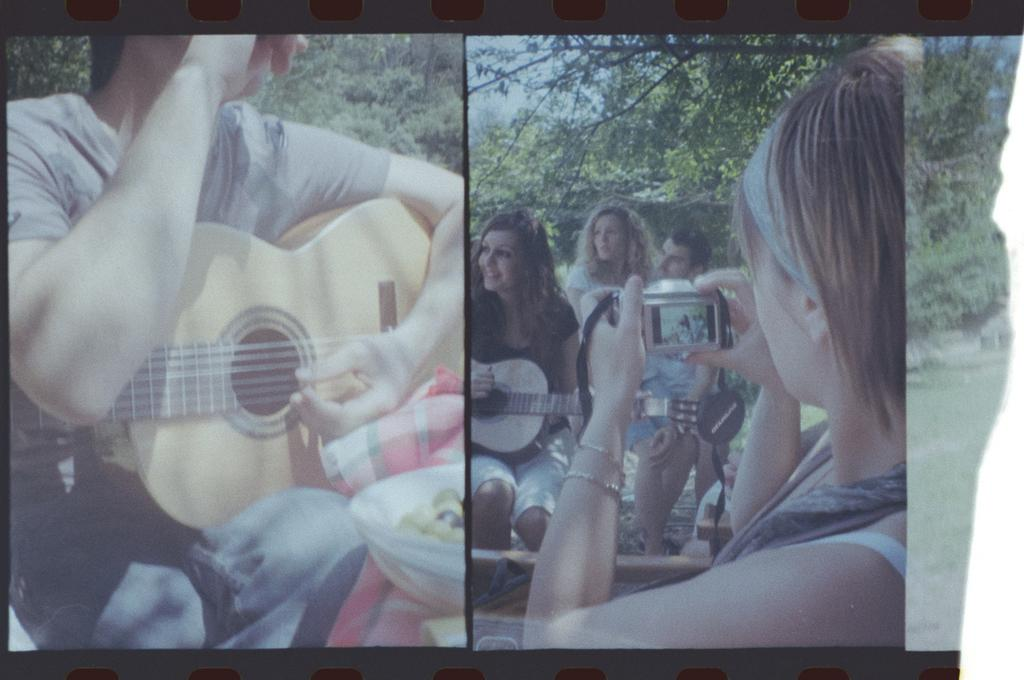What are the persons in the image doing? The persons in the image are sitting. What are two of the persons holding? Two persons are holding guitars. What is the third person holding? One person is holding a camera. What can be seen in the background of the image? There are trees in the background of the image. What type of vegetation is visible in the image? There is grass visible in the image. What type of lead can be seen connecting the guitar to the station in the image? There is no lead or station present in the image; the guitars are not connected to anything. How many bottles are visible in the image? There are no bottles visible in the image. 